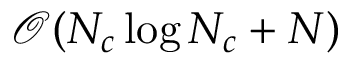Convert formula to latex. <formula><loc_0><loc_0><loc_500><loc_500>\ m a t h s c r { O } ( N _ { c } \log N _ { c } + N )</formula> 